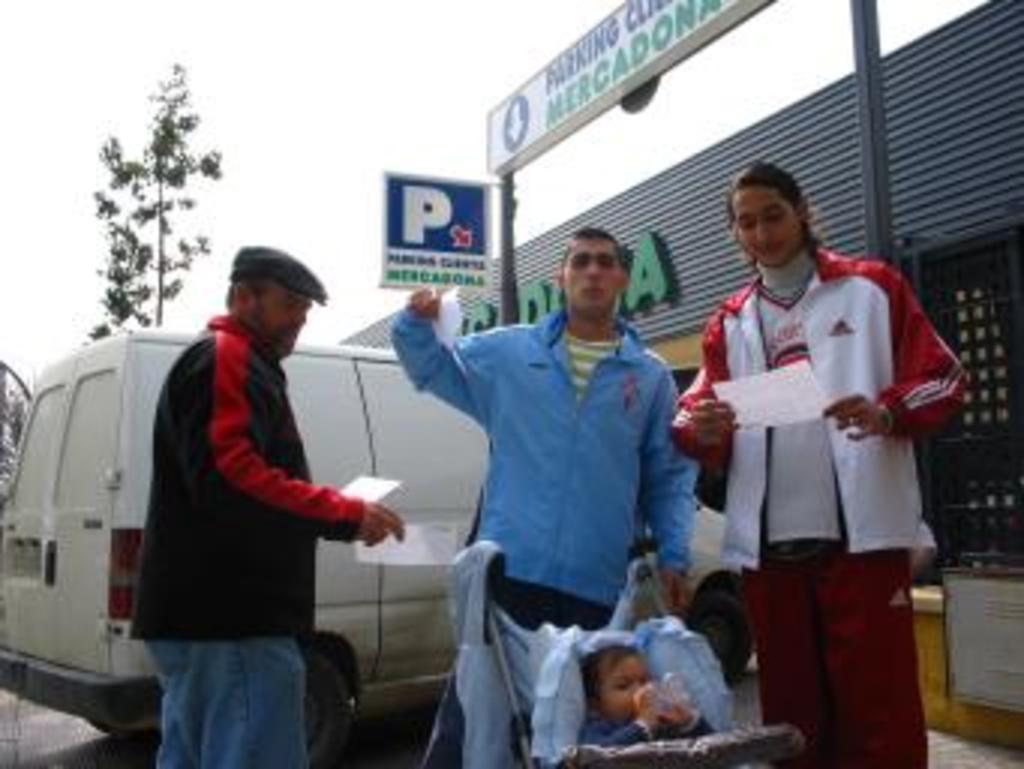How would you summarize this image in a sentence or two? In this picture I can observe three members and a baby in the stroller. Behind them I can observe white color vehicle. On the right side I can observe building. In the background I can observe tree and sky. 